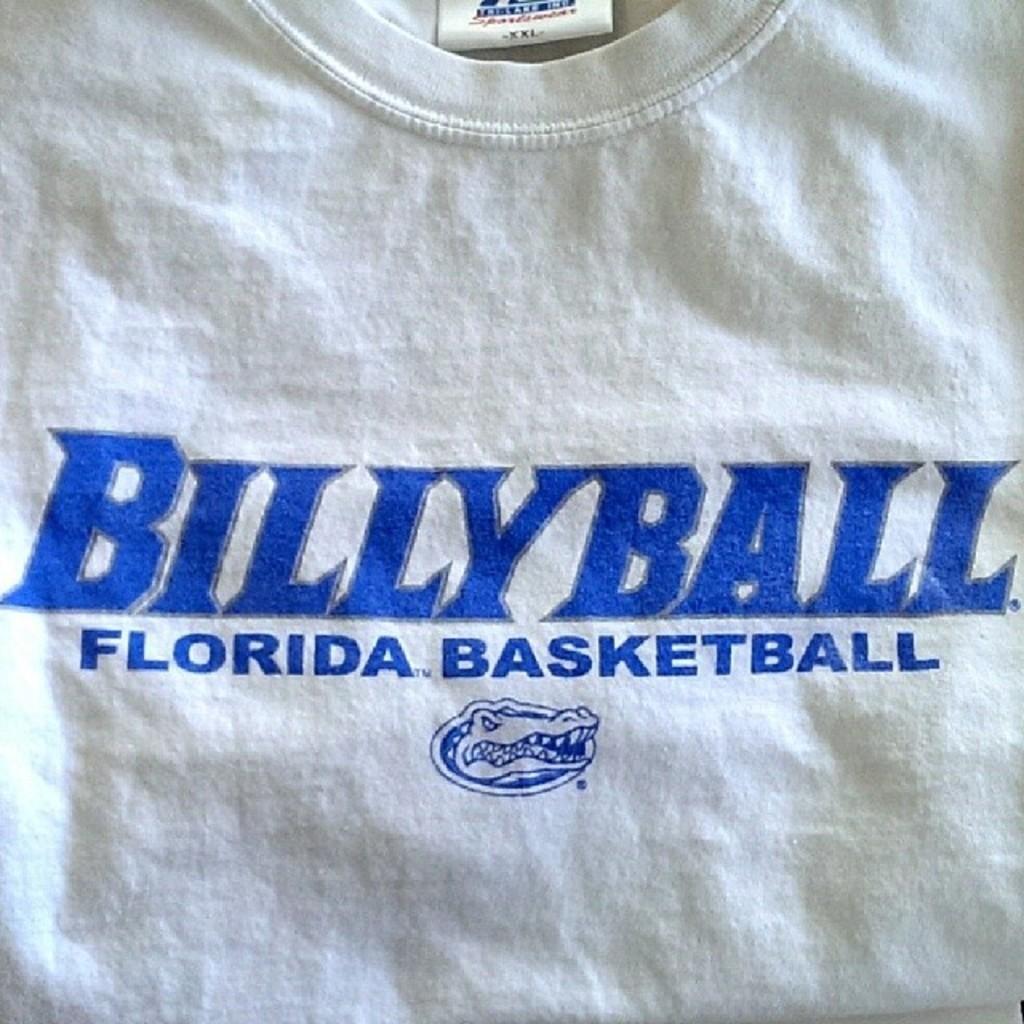What is the name of this program?
Make the answer very short. Billyball. 